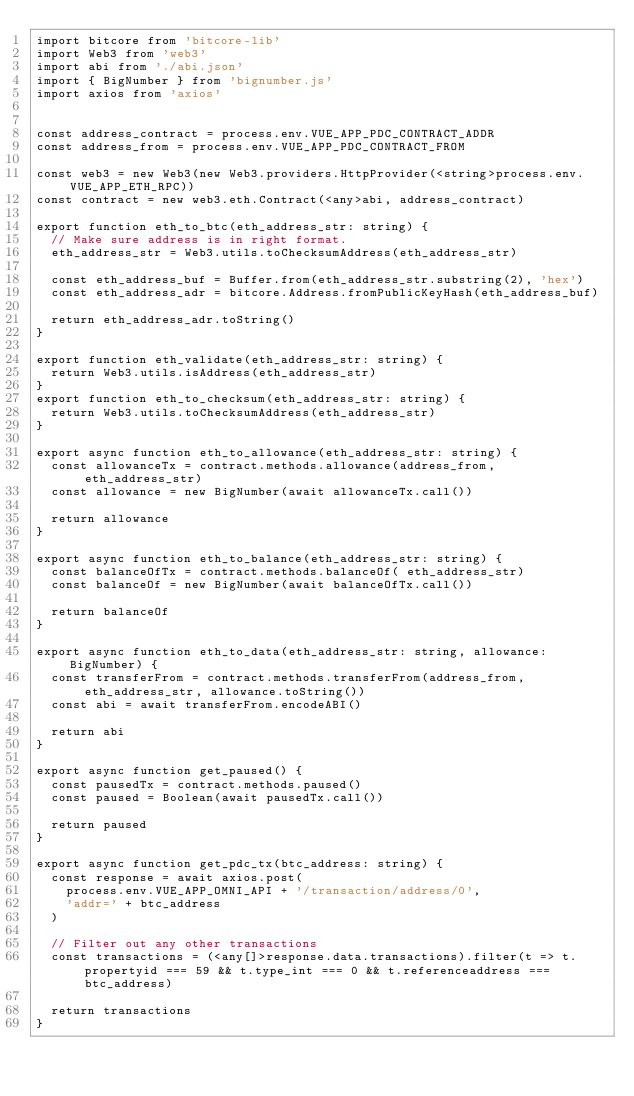Convert code to text. <code><loc_0><loc_0><loc_500><loc_500><_TypeScript_>import bitcore from 'bitcore-lib'
import Web3 from 'web3'
import abi from './abi.json'
import { BigNumber } from 'bignumber.js'
import axios from 'axios'


const address_contract = process.env.VUE_APP_PDC_CONTRACT_ADDR
const address_from = process.env.VUE_APP_PDC_CONTRACT_FROM

const web3 = new Web3(new Web3.providers.HttpProvider(<string>process.env.VUE_APP_ETH_RPC))
const contract = new web3.eth.Contract(<any>abi, address_contract)

export function eth_to_btc(eth_address_str: string) {
  // Make sure address is in right format.
  eth_address_str = Web3.utils.toChecksumAddress(eth_address_str)

  const eth_address_buf = Buffer.from(eth_address_str.substring(2), 'hex')
  const eth_address_adr = bitcore.Address.fromPublicKeyHash(eth_address_buf)

  return eth_address_adr.toString()
}

export function eth_validate(eth_address_str: string) {
  return Web3.utils.isAddress(eth_address_str)
}
export function eth_to_checksum(eth_address_str: string) {
  return Web3.utils.toChecksumAddress(eth_address_str)
}

export async function eth_to_allowance(eth_address_str: string) {
  const allowanceTx = contract.methods.allowance(address_from, eth_address_str)
  const allowance = new BigNumber(await allowanceTx.call())

  return allowance
}

export async function eth_to_balance(eth_address_str: string) {
  const balanceOfTx = contract.methods.balanceOf( eth_address_str)
  const balanceOf = new BigNumber(await balanceOfTx.call())

  return balanceOf
}

export async function eth_to_data(eth_address_str: string, allowance: BigNumber) {
  const transferFrom = contract.methods.transferFrom(address_from, eth_address_str, allowance.toString())
  const abi = await transferFrom.encodeABI()

  return abi
}

export async function get_paused() {
  const pausedTx = contract.methods.paused()
  const paused = Boolean(await pausedTx.call())

  return paused
}

export async function get_pdc_tx(btc_address: string) {
  const response = await axios.post(
    process.env.VUE_APP_OMNI_API + '/transaction/address/0',
    'addr=' + btc_address
  )

  // Filter out any other transactions
  const transactions = (<any[]>response.data.transactions).filter(t => t.propertyid === 59 && t.type_int === 0 && t.referenceaddress === btc_address)

  return transactions
}
</code> 